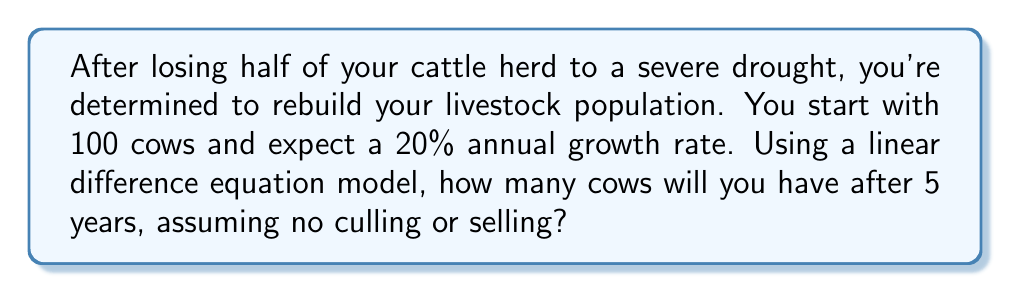Could you help me with this problem? Let's approach this step-by-step using a linear difference equation model:

1) Let $P_n$ represent the number of cows in year $n$.

2) The initial population is $P_0 = 100$ cows.

3) The growth rate is 20% or 0.20 per year.

4) The linear difference equation for this scenario is:

   $$P_{n+1} = P_n + 0.20P_n = 1.20P_n$$

5) We can calculate each year's population:
   
   Year 1: $P_1 = 1.20 \times 100 = 120$ cows
   Year 2: $P_2 = 1.20 \times 120 = 144$ cows
   Year 3: $P_3 = 1.20 \times 144 = 172.8$ cows
   Year 4: $P_4 = 1.20 \times 172.8 = 207.36$ cows
   Year 5: $P_5 = 1.20 \times 207.36 = 248.832$ cows

6) Alternatively, we can use the general formula:

   $$P_n = P_0 \times (1 + r)^n$$

   Where $P_0 = 100$, $r = 0.20$, and $n = 5$

   $$P_5 = 100 \times (1 + 0.20)^5 = 100 \times 1.20^5 = 248.832$$

7) Since we're dealing with whole cows, we round down to 248 cows.
Answer: 248 cows 